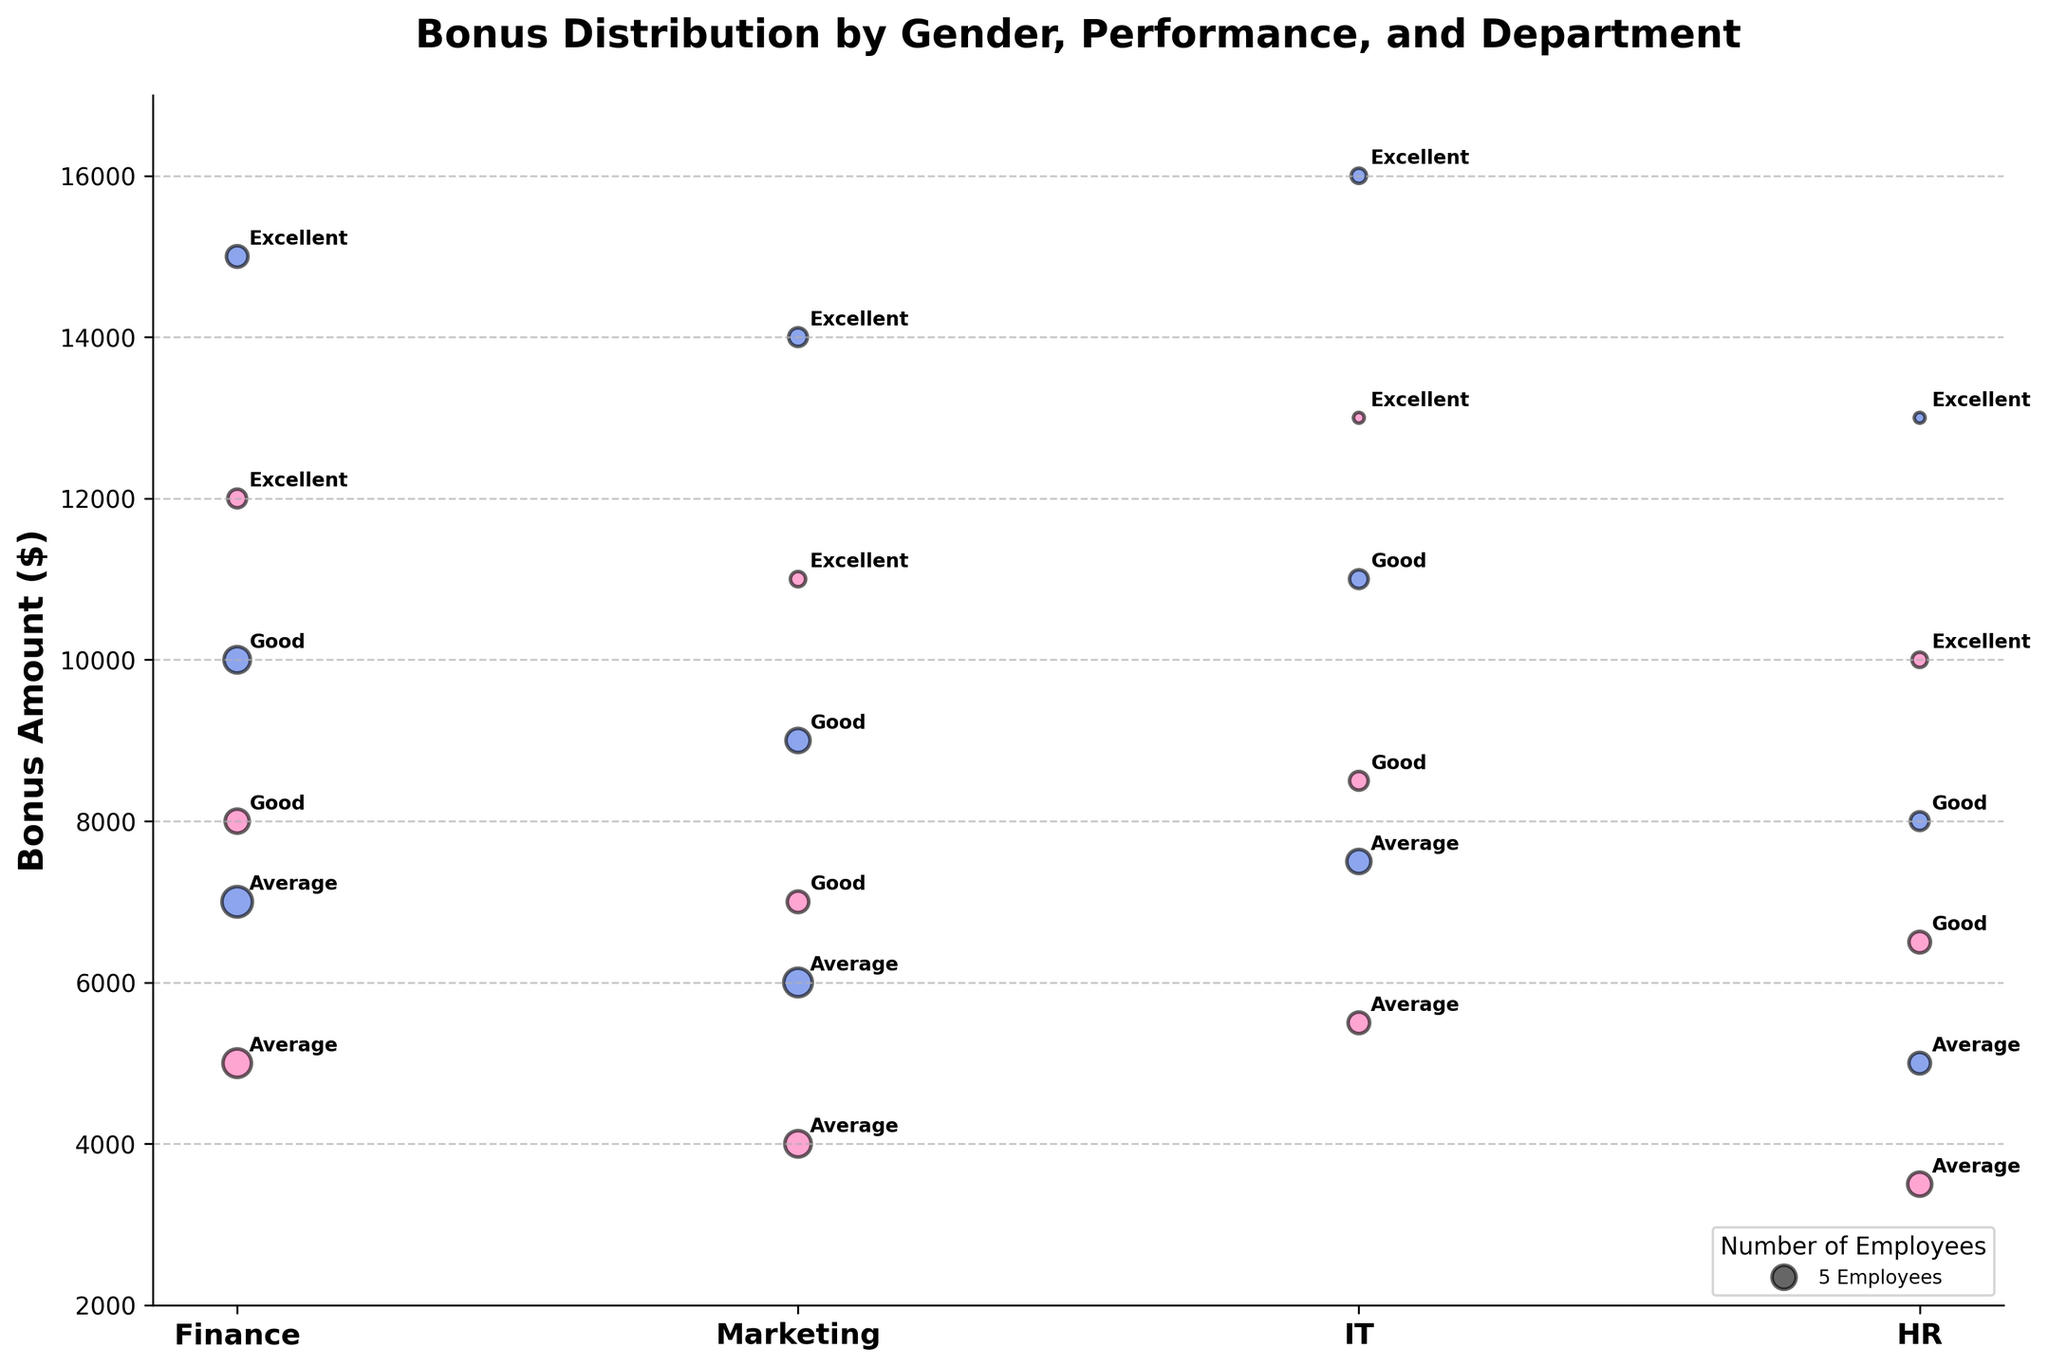What's the title of the figure? At the top of the figure, the title "Bonus Distribution by Gender, Performance, and Department" is displayed prominently.
Answer: Bonus Distribution by Gender, Performance, and Department What is the Y-axis labeled as? The Y-axis label indicates the metric being measured, which is "Bonus Amount ($)" and is written vertically on the left side.
Answer: Bonus Amount ($) Which department has the highest bonus amount for males with an "Excellent" performance rating? In the figure, the highest bonus amount for males with an "Excellent" rating is represented by the blue bubble that is the highest on the Y-axis. It is in the IT department.
Answer: IT What color represents females in the figure? The color representing females is consistently pink (#FF69B4) in the figure.
Answer: Pink How many employees are there in the Finance department for males with an "Excellent" rating? The size of the bubble can be related to the number of employees. In the Finance department, the size of the bubble for males with an "Excellent" rating reflects 4 employees.
Answer: 4 Among "Good" performance ratings, which gender has a higher bonus in Marketing? For "Good" performance ratings in Marketing, comparing the heights of bubbles of different colors reveals that males (blue) receive higher bonuses than females (pink).
Answer: Male What is the bonus amount for females in the HR department with an "Excellent" performance rating? The bonus amount for females in the HR department with an "Excellent" rating is identified by the pink bubble in the HR section, which is labeled and positioned at $10,000 on the Y-axis.
Answer: $10,000 Which department has the largest bubble for females with an "Average" performance rating? The size of the bubble indicates the number of employees. The largest bubble for females with an "Average" rating is in the Finance department.
Answer: Finance In which department is the difference in bonus amounts between males and females with "Excellent" performance the largest? By comparing the vertical distances between blue and pink bubbles with "Excellent" ratings across departments, the largest gap is observed in the IT department, where males receive $16,000 and females receive $13,000. The difference is $3,000.
Answer: IT What pattern is observed with respect to the bonus amounts and performance ratings across all departments and genders? Across all departments and genders, the trend shows that higher performance ratings ("Excellent") correspond to higher bonus amounts, medium performance ratings ("Good") get moderate bonuses, and lower performance ratings ("Average") receive the smallest bonuses.
Answer: Higher ratings have higher bonuses 